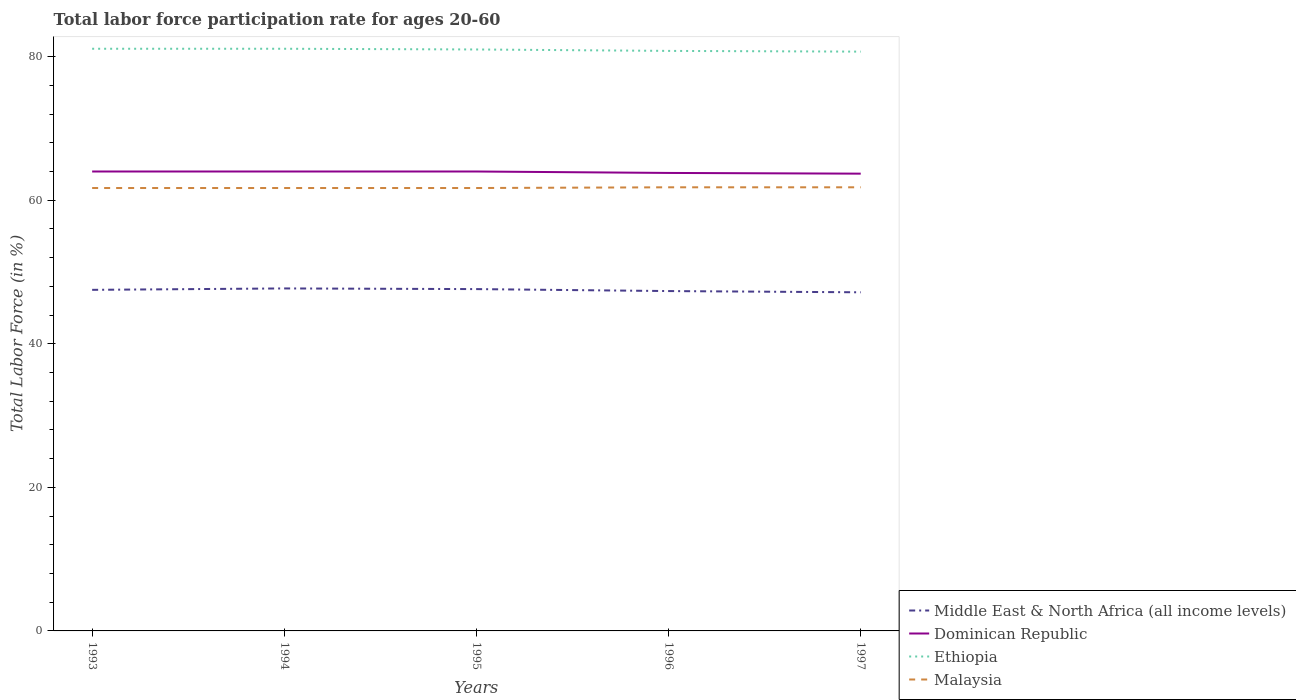How many different coloured lines are there?
Give a very brief answer. 4. Is the number of lines equal to the number of legend labels?
Give a very brief answer. Yes. Across all years, what is the maximum labor force participation rate in Dominican Republic?
Your response must be concise. 63.7. What is the total labor force participation rate in Ethiopia in the graph?
Your response must be concise. 0.3. What is the difference between the highest and the second highest labor force participation rate in Malaysia?
Offer a terse response. 0.1. Is the labor force participation rate in Ethiopia strictly greater than the labor force participation rate in Malaysia over the years?
Offer a very short reply. No. How many years are there in the graph?
Make the answer very short. 5. What is the difference between two consecutive major ticks on the Y-axis?
Your answer should be very brief. 20. How many legend labels are there?
Your answer should be compact. 4. What is the title of the graph?
Offer a very short reply. Total labor force participation rate for ages 20-60. What is the label or title of the X-axis?
Your answer should be very brief. Years. What is the label or title of the Y-axis?
Provide a short and direct response. Total Labor Force (in %). What is the Total Labor Force (in %) in Middle East & North Africa (all income levels) in 1993?
Your answer should be compact. 47.51. What is the Total Labor Force (in %) in Ethiopia in 1993?
Give a very brief answer. 81.1. What is the Total Labor Force (in %) of Malaysia in 1993?
Your answer should be compact. 61.7. What is the Total Labor Force (in %) in Middle East & North Africa (all income levels) in 1994?
Your answer should be very brief. 47.71. What is the Total Labor Force (in %) in Dominican Republic in 1994?
Offer a terse response. 64. What is the Total Labor Force (in %) in Ethiopia in 1994?
Your response must be concise. 81.1. What is the Total Labor Force (in %) in Malaysia in 1994?
Offer a terse response. 61.7. What is the Total Labor Force (in %) of Middle East & North Africa (all income levels) in 1995?
Offer a very short reply. 47.62. What is the Total Labor Force (in %) of Ethiopia in 1995?
Ensure brevity in your answer.  81. What is the Total Labor Force (in %) of Malaysia in 1995?
Offer a terse response. 61.7. What is the Total Labor Force (in %) of Middle East & North Africa (all income levels) in 1996?
Offer a very short reply. 47.34. What is the Total Labor Force (in %) in Dominican Republic in 1996?
Your answer should be very brief. 63.8. What is the Total Labor Force (in %) of Ethiopia in 1996?
Your answer should be compact. 80.8. What is the Total Labor Force (in %) of Malaysia in 1996?
Keep it short and to the point. 61.8. What is the Total Labor Force (in %) of Middle East & North Africa (all income levels) in 1997?
Offer a very short reply. 47.17. What is the Total Labor Force (in %) of Dominican Republic in 1997?
Offer a terse response. 63.7. What is the Total Labor Force (in %) of Ethiopia in 1997?
Provide a succinct answer. 80.7. What is the Total Labor Force (in %) in Malaysia in 1997?
Your answer should be very brief. 61.8. Across all years, what is the maximum Total Labor Force (in %) of Middle East & North Africa (all income levels)?
Make the answer very short. 47.71. Across all years, what is the maximum Total Labor Force (in %) of Dominican Republic?
Provide a succinct answer. 64. Across all years, what is the maximum Total Labor Force (in %) of Ethiopia?
Your answer should be very brief. 81.1. Across all years, what is the maximum Total Labor Force (in %) of Malaysia?
Provide a short and direct response. 61.8. Across all years, what is the minimum Total Labor Force (in %) of Middle East & North Africa (all income levels)?
Your response must be concise. 47.17. Across all years, what is the minimum Total Labor Force (in %) in Dominican Republic?
Your response must be concise. 63.7. Across all years, what is the minimum Total Labor Force (in %) in Ethiopia?
Offer a terse response. 80.7. Across all years, what is the minimum Total Labor Force (in %) in Malaysia?
Your response must be concise. 61.7. What is the total Total Labor Force (in %) in Middle East & North Africa (all income levels) in the graph?
Offer a terse response. 237.36. What is the total Total Labor Force (in %) of Dominican Republic in the graph?
Offer a very short reply. 319.5. What is the total Total Labor Force (in %) of Ethiopia in the graph?
Give a very brief answer. 404.7. What is the total Total Labor Force (in %) in Malaysia in the graph?
Offer a terse response. 308.7. What is the difference between the Total Labor Force (in %) in Middle East & North Africa (all income levels) in 1993 and that in 1994?
Give a very brief answer. -0.2. What is the difference between the Total Labor Force (in %) of Dominican Republic in 1993 and that in 1994?
Your answer should be very brief. 0. What is the difference between the Total Labor Force (in %) in Ethiopia in 1993 and that in 1994?
Give a very brief answer. 0. What is the difference between the Total Labor Force (in %) in Malaysia in 1993 and that in 1994?
Keep it short and to the point. 0. What is the difference between the Total Labor Force (in %) in Middle East & North Africa (all income levels) in 1993 and that in 1995?
Make the answer very short. -0.1. What is the difference between the Total Labor Force (in %) of Dominican Republic in 1993 and that in 1995?
Provide a short and direct response. 0. What is the difference between the Total Labor Force (in %) in Middle East & North Africa (all income levels) in 1993 and that in 1996?
Keep it short and to the point. 0.17. What is the difference between the Total Labor Force (in %) in Dominican Republic in 1993 and that in 1996?
Your answer should be compact. 0.2. What is the difference between the Total Labor Force (in %) of Middle East & North Africa (all income levels) in 1993 and that in 1997?
Ensure brevity in your answer.  0.34. What is the difference between the Total Labor Force (in %) in Malaysia in 1993 and that in 1997?
Provide a short and direct response. -0.1. What is the difference between the Total Labor Force (in %) in Middle East & North Africa (all income levels) in 1994 and that in 1995?
Ensure brevity in your answer.  0.09. What is the difference between the Total Labor Force (in %) in Ethiopia in 1994 and that in 1995?
Make the answer very short. 0.1. What is the difference between the Total Labor Force (in %) in Middle East & North Africa (all income levels) in 1994 and that in 1996?
Your answer should be compact. 0.37. What is the difference between the Total Labor Force (in %) of Dominican Republic in 1994 and that in 1996?
Your answer should be very brief. 0.2. What is the difference between the Total Labor Force (in %) of Ethiopia in 1994 and that in 1996?
Provide a succinct answer. 0.3. What is the difference between the Total Labor Force (in %) of Middle East & North Africa (all income levels) in 1994 and that in 1997?
Provide a succinct answer. 0.54. What is the difference between the Total Labor Force (in %) of Ethiopia in 1994 and that in 1997?
Your answer should be compact. 0.4. What is the difference between the Total Labor Force (in %) in Middle East & North Africa (all income levels) in 1995 and that in 1996?
Offer a terse response. 0.27. What is the difference between the Total Labor Force (in %) of Dominican Republic in 1995 and that in 1996?
Your answer should be very brief. 0.2. What is the difference between the Total Labor Force (in %) of Ethiopia in 1995 and that in 1996?
Make the answer very short. 0.2. What is the difference between the Total Labor Force (in %) in Middle East & North Africa (all income levels) in 1995 and that in 1997?
Offer a terse response. 0.45. What is the difference between the Total Labor Force (in %) in Dominican Republic in 1995 and that in 1997?
Offer a terse response. 0.3. What is the difference between the Total Labor Force (in %) of Middle East & North Africa (all income levels) in 1996 and that in 1997?
Keep it short and to the point. 0.17. What is the difference between the Total Labor Force (in %) in Malaysia in 1996 and that in 1997?
Keep it short and to the point. 0. What is the difference between the Total Labor Force (in %) in Middle East & North Africa (all income levels) in 1993 and the Total Labor Force (in %) in Dominican Republic in 1994?
Give a very brief answer. -16.49. What is the difference between the Total Labor Force (in %) in Middle East & North Africa (all income levels) in 1993 and the Total Labor Force (in %) in Ethiopia in 1994?
Give a very brief answer. -33.59. What is the difference between the Total Labor Force (in %) of Middle East & North Africa (all income levels) in 1993 and the Total Labor Force (in %) of Malaysia in 1994?
Your response must be concise. -14.19. What is the difference between the Total Labor Force (in %) of Dominican Republic in 1993 and the Total Labor Force (in %) of Ethiopia in 1994?
Your answer should be very brief. -17.1. What is the difference between the Total Labor Force (in %) of Dominican Republic in 1993 and the Total Labor Force (in %) of Malaysia in 1994?
Keep it short and to the point. 2.3. What is the difference between the Total Labor Force (in %) in Middle East & North Africa (all income levels) in 1993 and the Total Labor Force (in %) in Dominican Republic in 1995?
Offer a terse response. -16.49. What is the difference between the Total Labor Force (in %) in Middle East & North Africa (all income levels) in 1993 and the Total Labor Force (in %) in Ethiopia in 1995?
Give a very brief answer. -33.49. What is the difference between the Total Labor Force (in %) of Middle East & North Africa (all income levels) in 1993 and the Total Labor Force (in %) of Malaysia in 1995?
Provide a succinct answer. -14.19. What is the difference between the Total Labor Force (in %) of Dominican Republic in 1993 and the Total Labor Force (in %) of Malaysia in 1995?
Your answer should be compact. 2.3. What is the difference between the Total Labor Force (in %) in Middle East & North Africa (all income levels) in 1993 and the Total Labor Force (in %) in Dominican Republic in 1996?
Offer a terse response. -16.29. What is the difference between the Total Labor Force (in %) of Middle East & North Africa (all income levels) in 1993 and the Total Labor Force (in %) of Ethiopia in 1996?
Provide a short and direct response. -33.29. What is the difference between the Total Labor Force (in %) in Middle East & North Africa (all income levels) in 1993 and the Total Labor Force (in %) in Malaysia in 1996?
Offer a very short reply. -14.29. What is the difference between the Total Labor Force (in %) in Dominican Republic in 1993 and the Total Labor Force (in %) in Ethiopia in 1996?
Offer a very short reply. -16.8. What is the difference between the Total Labor Force (in %) in Dominican Republic in 1993 and the Total Labor Force (in %) in Malaysia in 1996?
Provide a short and direct response. 2.2. What is the difference between the Total Labor Force (in %) in Ethiopia in 1993 and the Total Labor Force (in %) in Malaysia in 1996?
Keep it short and to the point. 19.3. What is the difference between the Total Labor Force (in %) of Middle East & North Africa (all income levels) in 1993 and the Total Labor Force (in %) of Dominican Republic in 1997?
Ensure brevity in your answer.  -16.19. What is the difference between the Total Labor Force (in %) of Middle East & North Africa (all income levels) in 1993 and the Total Labor Force (in %) of Ethiopia in 1997?
Make the answer very short. -33.19. What is the difference between the Total Labor Force (in %) of Middle East & North Africa (all income levels) in 1993 and the Total Labor Force (in %) of Malaysia in 1997?
Give a very brief answer. -14.29. What is the difference between the Total Labor Force (in %) of Dominican Republic in 1993 and the Total Labor Force (in %) of Ethiopia in 1997?
Offer a terse response. -16.7. What is the difference between the Total Labor Force (in %) of Dominican Republic in 1993 and the Total Labor Force (in %) of Malaysia in 1997?
Provide a short and direct response. 2.2. What is the difference between the Total Labor Force (in %) of Ethiopia in 1993 and the Total Labor Force (in %) of Malaysia in 1997?
Make the answer very short. 19.3. What is the difference between the Total Labor Force (in %) in Middle East & North Africa (all income levels) in 1994 and the Total Labor Force (in %) in Dominican Republic in 1995?
Your answer should be very brief. -16.29. What is the difference between the Total Labor Force (in %) of Middle East & North Africa (all income levels) in 1994 and the Total Labor Force (in %) of Ethiopia in 1995?
Keep it short and to the point. -33.29. What is the difference between the Total Labor Force (in %) of Middle East & North Africa (all income levels) in 1994 and the Total Labor Force (in %) of Malaysia in 1995?
Ensure brevity in your answer.  -13.99. What is the difference between the Total Labor Force (in %) in Dominican Republic in 1994 and the Total Labor Force (in %) in Ethiopia in 1995?
Provide a succinct answer. -17. What is the difference between the Total Labor Force (in %) of Dominican Republic in 1994 and the Total Labor Force (in %) of Malaysia in 1995?
Give a very brief answer. 2.3. What is the difference between the Total Labor Force (in %) in Middle East & North Africa (all income levels) in 1994 and the Total Labor Force (in %) in Dominican Republic in 1996?
Ensure brevity in your answer.  -16.09. What is the difference between the Total Labor Force (in %) of Middle East & North Africa (all income levels) in 1994 and the Total Labor Force (in %) of Ethiopia in 1996?
Provide a succinct answer. -33.09. What is the difference between the Total Labor Force (in %) in Middle East & North Africa (all income levels) in 1994 and the Total Labor Force (in %) in Malaysia in 1996?
Offer a very short reply. -14.09. What is the difference between the Total Labor Force (in %) in Dominican Republic in 1994 and the Total Labor Force (in %) in Ethiopia in 1996?
Make the answer very short. -16.8. What is the difference between the Total Labor Force (in %) in Dominican Republic in 1994 and the Total Labor Force (in %) in Malaysia in 1996?
Provide a succinct answer. 2.2. What is the difference between the Total Labor Force (in %) of Ethiopia in 1994 and the Total Labor Force (in %) of Malaysia in 1996?
Keep it short and to the point. 19.3. What is the difference between the Total Labor Force (in %) of Middle East & North Africa (all income levels) in 1994 and the Total Labor Force (in %) of Dominican Republic in 1997?
Provide a succinct answer. -15.99. What is the difference between the Total Labor Force (in %) in Middle East & North Africa (all income levels) in 1994 and the Total Labor Force (in %) in Ethiopia in 1997?
Ensure brevity in your answer.  -32.99. What is the difference between the Total Labor Force (in %) of Middle East & North Africa (all income levels) in 1994 and the Total Labor Force (in %) of Malaysia in 1997?
Keep it short and to the point. -14.09. What is the difference between the Total Labor Force (in %) of Dominican Republic in 1994 and the Total Labor Force (in %) of Ethiopia in 1997?
Provide a succinct answer. -16.7. What is the difference between the Total Labor Force (in %) in Dominican Republic in 1994 and the Total Labor Force (in %) in Malaysia in 1997?
Your answer should be compact. 2.2. What is the difference between the Total Labor Force (in %) of Ethiopia in 1994 and the Total Labor Force (in %) of Malaysia in 1997?
Provide a short and direct response. 19.3. What is the difference between the Total Labor Force (in %) of Middle East & North Africa (all income levels) in 1995 and the Total Labor Force (in %) of Dominican Republic in 1996?
Keep it short and to the point. -16.18. What is the difference between the Total Labor Force (in %) in Middle East & North Africa (all income levels) in 1995 and the Total Labor Force (in %) in Ethiopia in 1996?
Provide a succinct answer. -33.18. What is the difference between the Total Labor Force (in %) in Middle East & North Africa (all income levels) in 1995 and the Total Labor Force (in %) in Malaysia in 1996?
Provide a succinct answer. -14.18. What is the difference between the Total Labor Force (in %) in Dominican Republic in 1995 and the Total Labor Force (in %) in Ethiopia in 1996?
Your response must be concise. -16.8. What is the difference between the Total Labor Force (in %) in Dominican Republic in 1995 and the Total Labor Force (in %) in Malaysia in 1996?
Offer a very short reply. 2.2. What is the difference between the Total Labor Force (in %) of Ethiopia in 1995 and the Total Labor Force (in %) of Malaysia in 1996?
Offer a very short reply. 19.2. What is the difference between the Total Labor Force (in %) in Middle East & North Africa (all income levels) in 1995 and the Total Labor Force (in %) in Dominican Republic in 1997?
Provide a succinct answer. -16.08. What is the difference between the Total Labor Force (in %) in Middle East & North Africa (all income levels) in 1995 and the Total Labor Force (in %) in Ethiopia in 1997?
Ensure brevity in your answer.  -33.08. What is the difference between the Total Labor Force (in %) of Middle East & North Africa (all income levels) in 1995 and the Total Labor Force (in %) of Malaysia in 1997?
Offer a terse response. -14.18. What is the difference between the Total Labor Force (in %) of Dominican Republic in 1995 and the Total Labor Force (in %) of Ethiopia in 1997?
Your response must be concise. -16.7. What is the difference between the Total Labor Force (in %) in Middle East & North Africa (all income levels) in 1996 and the Total Labor Force (in %) in Dominican Republic in 1997?
Ensure brevity in your answer.  -16.36. What is the difference between the Total Labor Force (in %) of Middle East & North Africa (all income levels) in 1996 and the Total Labor Force (in %) of Ethiopia in 1997?
Your answer should be compact. -33.36. What is the difference between the Total Labor Force (in %) in Middle East & North Africa (all income levels) in 1996 and the Total Labor Force (in %) in Malaysia in 1997?
Offer a very short reply. -14.46. What is the difference between the Total Labor Force (in %) in Dominican Republic in 1996 and the Total Labor Force (in %) in Ethiopia in 1997?
Provide a short and direct response. -16.9. What is the difference between the Total Labor Force (in %) of Dominican Republic in 1996 and the Total Labor Force (in %) of Malaysia in 1997?
Your answer should be compact. 2. What is the difference between the Total Labor Force (in %) of Ethiopia in 1996 and the Total Labor Force (in %) of Malaysia in 1997?
Your answer should be very brief. 19. What is the average Total Labor Force (in %) of Middle East & North Africa (all income levels) per year?
Your answer should be compact. 47.47. What is the average Total Labor Force (in %) in Dominican Republic per year?
Your response must be concise. 63.9. What is the average Total Labor Force (in %) in Ethiopia per year?
Ensure brevity in your answer.  80.94. What is the average Total Labor Force (in %) in Malaysia per year?
Offer a very short reply. 61.74. In the year 1993, what is the difference between the Total Labor Force (in %) in Middle East & North Africa (all income levels) and Total Labor Force (in %) in Dominican Republic?
Provide a short and direct response. -16.49. In the year 1993, what is the difference between the Total Labor Force (in %) of Middle East & North Africa (all income levels) and Total Labor Force (in %) of Ethiopia?
Offer a very short reply. -33.59. In the year 1993, what is the difference between the Total Labor Force (in %) in Middle East & North Africa (all income levels) and Total Labor Force (in %) in Malaysia?
Ensure brevity in your answer.  -14.19. In the year 1993, what is the difference between the Total Labor Force (in %) in Dominican Republic and Total Labor Force (in %) in Ethiopia?
Keep it short and to the point. -17.1. In the year 1993, what is the difference between the Total Labor Force (in %) in Dominican Republic and Total Labor Force (in %) in Malaysia?
Provide a succinct answer. 2.3. In the year 1994, what is the difference between the Total Labor Force (in %) in Middle East & North Africa (all income levels) and Total Labor Force (in %) in Dominican Republic?
Your response must be concise. -16.29. In the year 1994, what is the difference between the Total Labor Force (in %) of Middle East & North Africa (all income levels) and Total Labor Force (in %) of Ethiopia?
Your answer should be compact. -33.39. In the year 1994, what is the difference between the Total Labor Force (in %) in Middle East & North Africa (all income levels) and Total Labor Force (in %) in Malaysia?
Your answer should be very brief. -13.99. In the year 1994, what is the difference between the Total Labor Force (in %) of Dominican Republic and Total Labor Force (in %) of Ethiopia?
Your response must be concise. -17.1. In the year 1995, what is the difference between the Total Labor Force (in %) of Middle East & North Africa (all income levels) and Total Labor Force (in %) of Dominican Republic?
Provide a succinct answer. -16.38. In the year 1995, what is the difference between the Total Labor Force (in %) in Middle East & North Africa (all income levels) and Total Labor Force (in %) in Ethiopia?
Your answer should be very brief. -33.38. In the year 1995, what is the difference between the Total Labor Force (in %) of Middle East & North Africa (all income levels) and Total Labor Force (in %) of Malaysia?
Provide a short and direct response. -14.08. In the year 1995, what is the difference between the Total Labor Force (in %) of Dominican Republic and Total Labor Force (in %) of Malaysia?
Ensure brevity in your answer.  2.3. In the year 1995, what is the difference between the Total Labor Force (in %) in Ethiopia and Total Labor Force (in %) in Malaysia?
Keep it short and to the point. 19.3. In the year 1996, what is the difference between the Total Labor Force (in %) of Middle East & North Africa (all income levels) and Total Labor Force (in %) of Dominican Republic?
Your answer should be very brief. -16.46. In the year 1996, what is the difference between the Total Labor Force (in %) in Middle East & North Africa (all income levels) and Total Labor Force (in %) in Ethiopia?
Give a very brief answer. -33.46. In the year 1996, what is the difference between the Total Labor Force (in %) in Middle East & North Africa (all income levels) and Total Labor Force (in %) in Malaysia?
Make the answer very short. -14.46. In the year 1996, what is the difference between the Total Labor Force (in %) of Dominican Republic and Total Labor Force (in %) of Ethiopia?
Provide a succinct answer. -17. In the year 1997, what is the difference between the Total Labor Force (in %) in Middle East & North Africa (all income levels) and Total Labor Force (in %) in Dominican Republic?
Make the answer very short. -16.53. In the year 1997, what is the difference between the Total Labor Force (in %) in Middle East & North Africa (all income levels) and Total Labor Force (in %) in Ethiopia?
Ensure brevity in your answer.  -33.53. In the year 1997, what is the difference between the Total Labor Force (in %) of Middle East & North Africa (all income levels) and Total Labor Force (in %) of Malaysia?
Your response must be concise. -14.63. What is the ratio of the Total Labor Force (in %) in Middle East & North Africa (all income levels) in 1993 to that in 1994?
Your answer should be compact. 1. What is the ratio of the Total Labor Force (in %) in Ethiopia in 1993 to that in 1994?
Give a very brief answer. 1. What is the ratio of the Total Labor Force (in %) of Ethiopia in 1993 to that in 1995?
Your response must be concise. 1. What is the ratio of the Total Labor Force (in %) in Malaysia in 1993 to that in 1995?
Your response must be concise. 1. What is the ratio of the Total Labor Force (in %) of Ethiopia in 1993 to that in 1996?
Provide a short and direct response. 1. What is the ratio of the Total Labor Force (in %) of Malaysia in 1993 to that in 1996?
Provide a short and direct response. 1. What is the ratio of the Total Labor Force (in %) in Middle East & North Africa (all income levels) in 1993 to that in 1997?
Your answer should be compact. 1.01. What is the ratio of the Total Labor Force (in %) of Dominican Republic in 1993 to that in 1997?
Make the answer very short. 1. What is the ratio of the Total Labor Force (in %) in Dominican Republic in 1994 to that in 1995?
Offer a very short reply. 1. What is the ratio of the Total Labor Force (in %) of Malaysia in 1994 to that in 1995?
Offer a terse response. 1. What is the ratio of the Total Labor Force (in %) of Middle East & North Africa (all income levels) in 1994 to that in 1996?
Your answer should be very brief. 1.01. What is the ratio of the Total Labor Force (in %) in Dominican Republic in 1994 to that in 1996?
Give a very brief answer. 1. What is the ratio of the Total Labor Force (in %) of Middle East & North Africa (all income levels) in 1994 to that in 1997?
Your response must be concise. 1.01. What is the ratio of the Total Labor Force (in %) in Dominican Republic in 1994 to that in 1997?
Offer a terse response. 1. What is the ratio of the Total Labor Force (in %) in Ethiopia in 1994 to that in 1997?
Offer a very short reply. 1. What is the ratio of the Total Labor Force (in %) of Middle East & North Africa (all income levels) in 1995 to that in 1996?
Offer a very short reply. 1.01. What is the ratio of the Total Labor Force (in %) of Dominican Republic in 1995 to that in 1996?
Provide a short and direct response. 1. What is the ratio of the Total Labor Force (in %) in Middle East & North Africa (all income levels) in 1995 to that in 1997?
Offer a terse response. 1.01. What is the ratio of the Total Labor Force (in %) in Ethiopia in 1995 to that in 1997?
Your answer should be very brief. 1. What is the ratio of the Total Labor Force (in %) of Malaysia in 1995 to that in 1997?
Your answer should be very brief. 1. What is the ratio of the Total Labor Force (in %) in Middle East & North Africa (all income levels) in 1996 to that in 1997?
Your answer should be very brief. 1. What is the ratio of the Total Labor Force (in %) of Dominican Republic in 1996 to that in 1997?
Your answer should be very brief. 1. What is the difference between the highest and the second highest Total Labor Force (in %) of Middle East & North Africa (all income levels)?
Offer a very short reply. 0.09. What is the difference between the highest and the second highest Total Labor Force (in %) of Dominican Republic?
Your answer should be compact. 0. What is the difference between the highest and the second highest Total Labor Force (in %) in Malaysia?
Your answer should be very brief. 0. What is the difference between the highest and the lowest Total Labor Force (in %) in Middle East & North Africa (all income levels)?
Provide a succinct answer. 0.54. What is the difference between the highest and the lowest Total Labor Force (in %) in Dominican Republic?
Your response must be concise. 0.3. What is the difference between the highest and the lowest Total Labor Force (in %) of Ethiopia?
Your answer should be very brief. 0.4. 